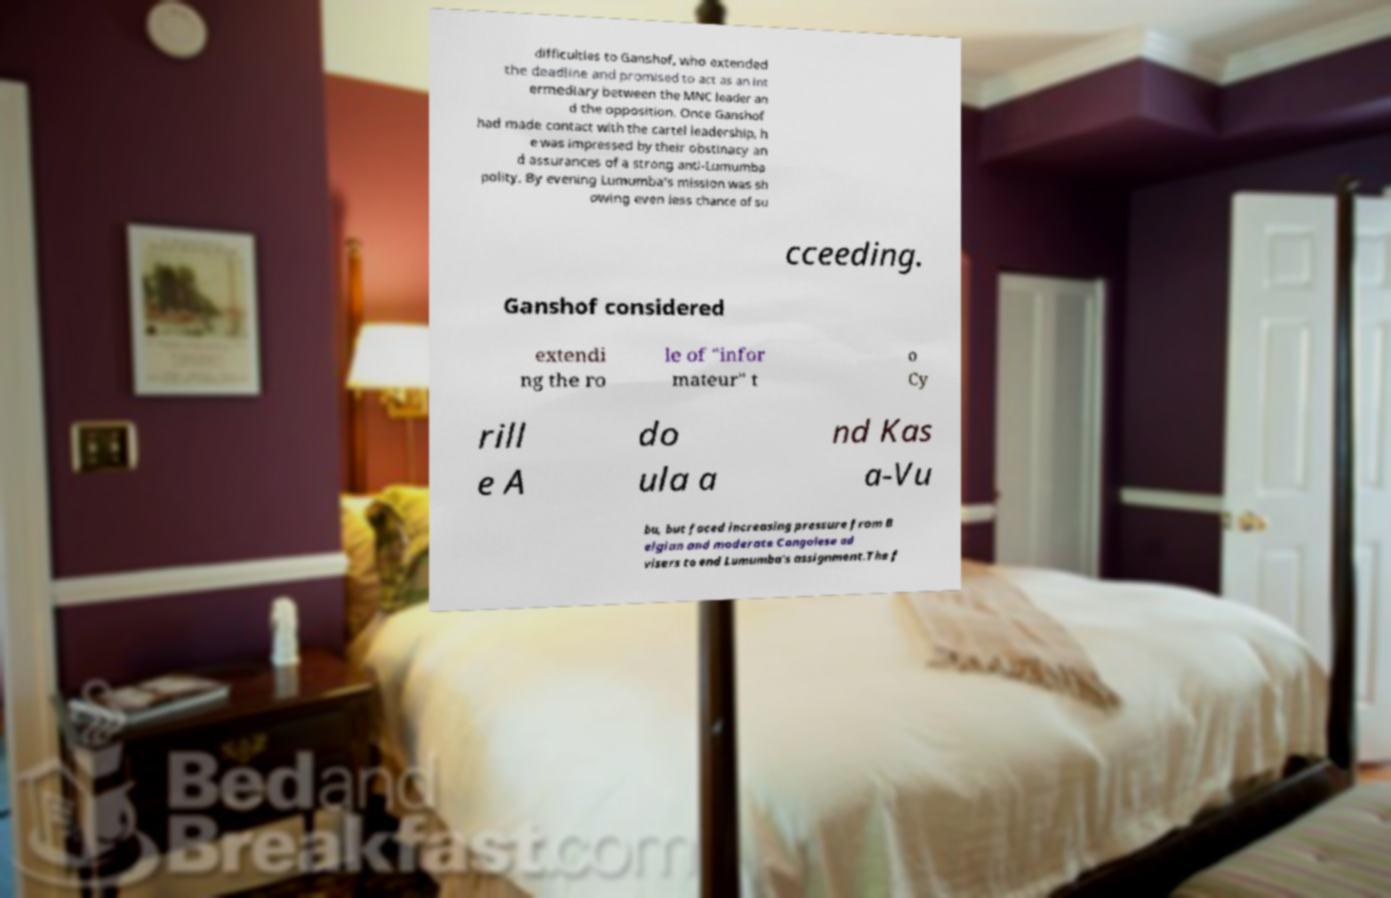Can you accurately transcribe the text from the provided image for me? difficulties to Ganshof, who extended the deadline and promised to act as an int ermediary between the MNC leader an d the opposition. Once Ganshof had made contact with the cartel leadership, h e was impressed by their obstinacy an d assurances of a strong anti-Lumumba polity. By evening Lumumba's mission was sh owing even less chance of su cceeding. Ganshof considered extendi ng the ro le of "infor mateur" t o Cy rill e A do ula a nd Kas a-Vu bu, but faced increasing pressure from B elgian and moderate Congolese ad visers to end Lumumba's assignment.The f 